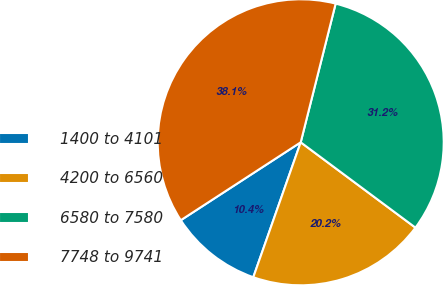Convert chart. <chart><loc_0><loc_0><loc_500><loc_500><pie_chart><fcel>1400 to 4101<fcel>4200 to 6560<fcel>6580 to 7580<fcel>7748 to 9741<nl><fcel>10.45%<fcel>20.2%<fcel>31.25%<fcel>38.1%<nl></chart> 